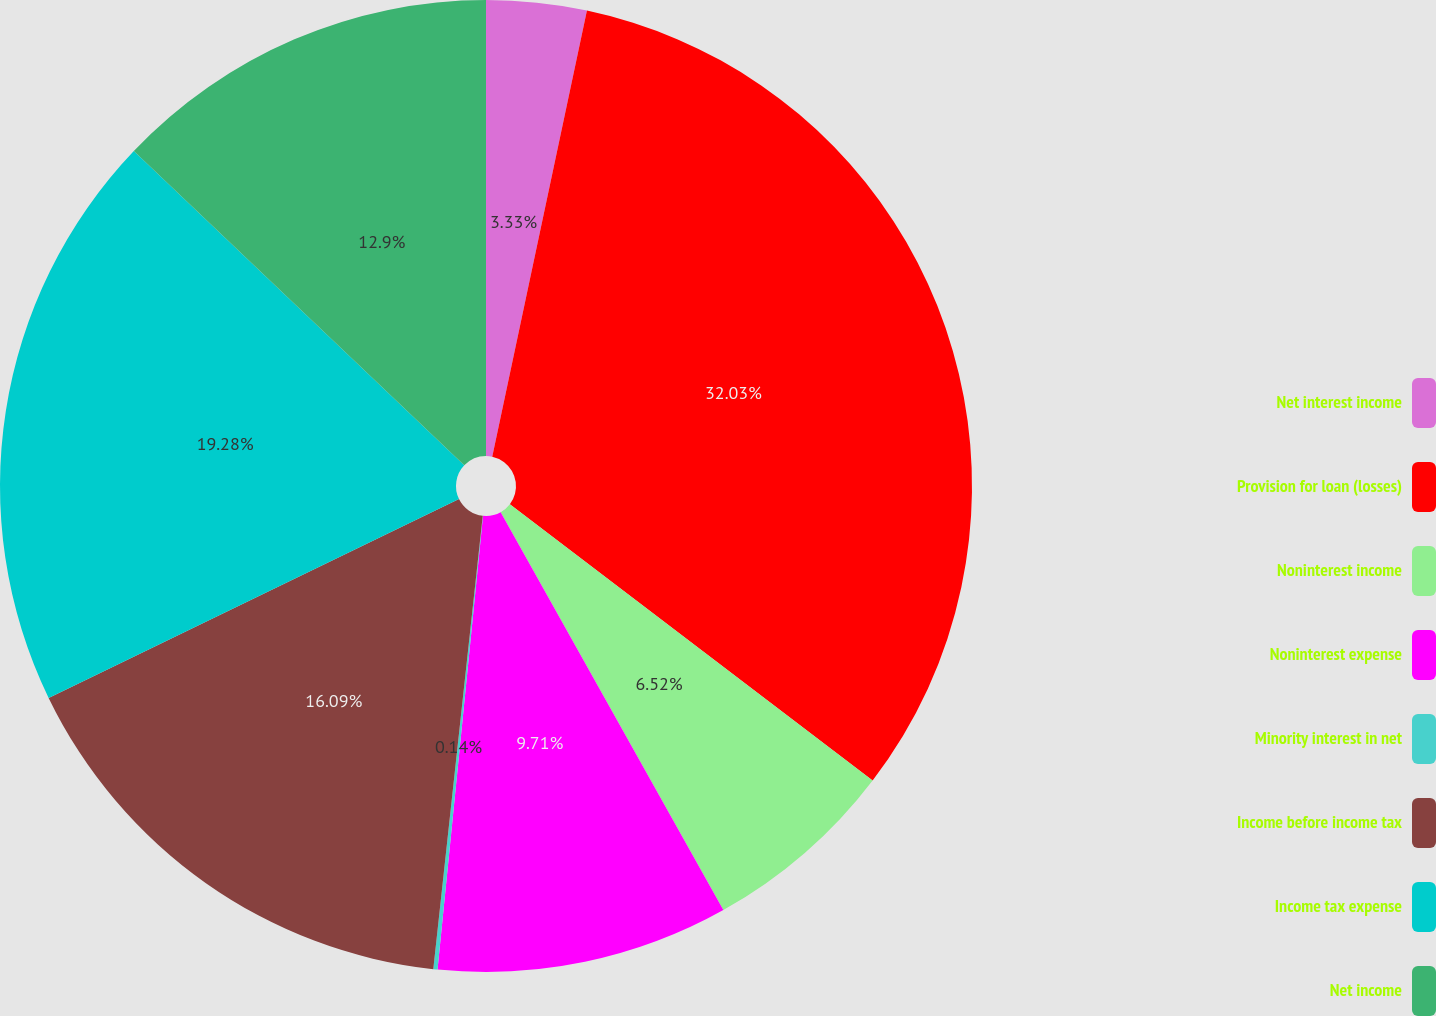<chart> <loc_0><loc_0><loc_500><loc_500><pie_chart><fcel>Net interest income<fcel>Provision for loan (losses)<fcel>Noninterest income<fcel>Noninterest expense<fcel>Minority interest in net<fcel>Income before income tax<fcel>Income tax expense<fcel>Net income<nl><fcel>3.33%<fcel>32.03%<fcel>6.52%<fcel>9.71%<fcel>0.14%<fcel>16.09%<fcel>19.28%<fcel>12.9%<nl></chart> 